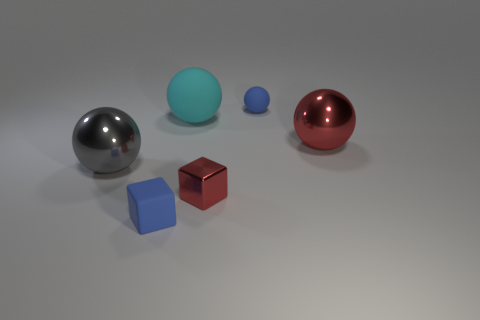Subtract all red spheres. How many spheres are left? 3 Subtract all blue blocks. How many blocks are left? 1 Subtract 1 blocks. How many blocks are left? 1 Add 1 shiny balls. How many objects exist? 7 Subtract all green balls. How many blue blocks are left? 1 Add 1 big cyan rubber spheres. How many big cyan rubber spheres exist? 2 Subtract 0 yellow cubes. How many objects are left? 6 Subtract all cubes. How many objects are left? 4 Subtract all purple balls. Subtract all yellow cylinders. How many balls are left? 4 Subtract all cyan things. Subtract all blocks. How many objects are left? 3 